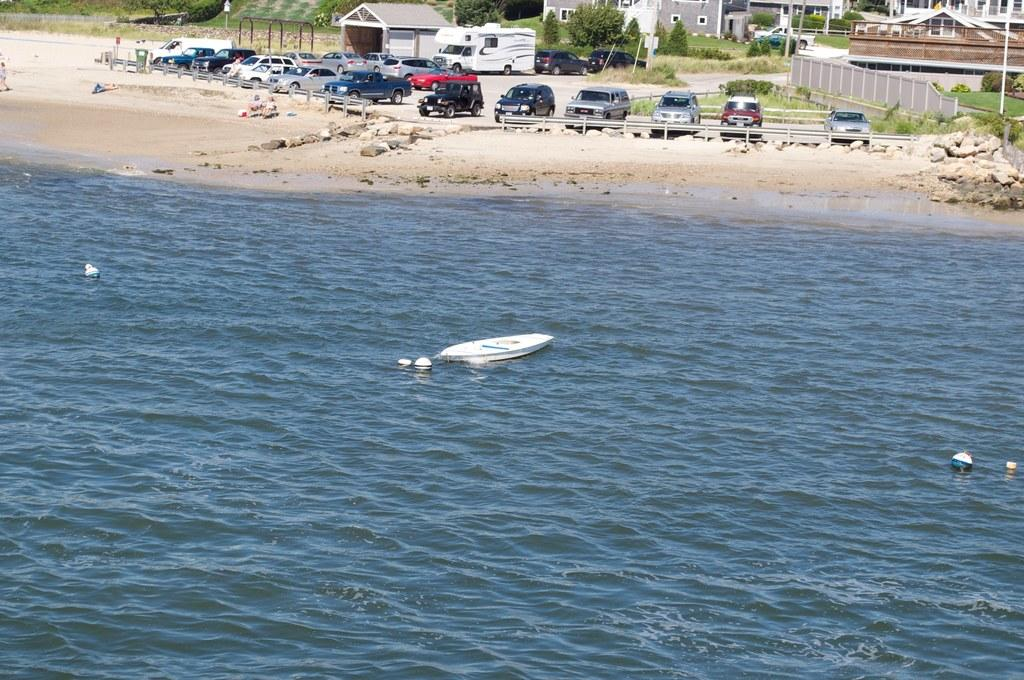What type of body of water is visible in the image? There is a sea in the image. What is floating on the surface of the sea? A boat is present on the surface of the sea. What can be seen in the background of the image? Cars, trees, plants, and buildings are visible in the background of the image. What type of prose can be heard coming from the boat in the image? There is no indication in the image that any prose is being spoken or heard, as the image only shows a sea, a boat, and the background elements. 